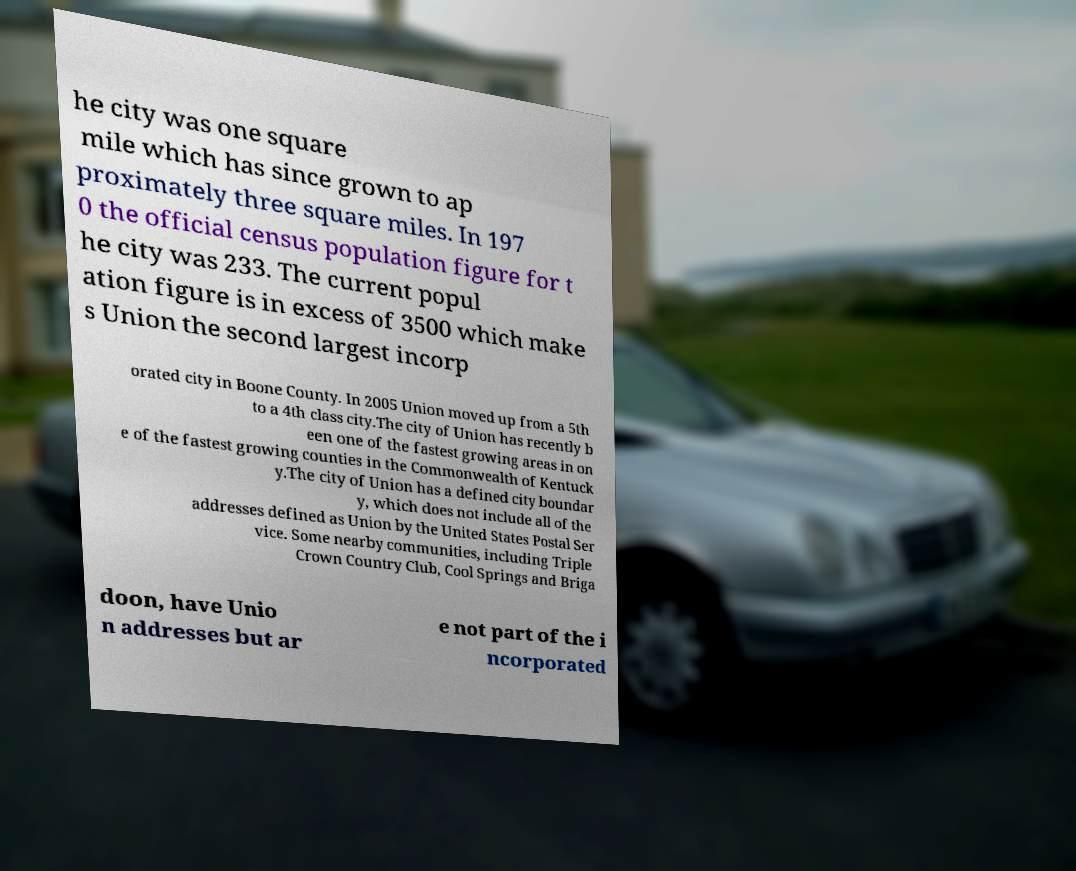Could you assist in decoding the text presented in this image and type it out clearly? he city was one square mile which has since grown to ap proximately three square miles. In 197 0 the official census population figure for t he city was 233. The current popul ation figure is in excess of 3500 which make s Union the second largest incorp orated city in Boone County. In 2005 Union moved up from a 5th to a 4th class city.The city of Union has recently b een one of the fastest growing areas in on e of the fastest growing counties in the Commonwealth of Kentuck y.The city of Union has a defined city boundar y, which does not include all of the addresses defined as Union by the United States Postal Ser vice. Some nearby communities, including Triple Crown Country Club, Cool Springs and Briga doon, have Unio n addresses but ar e not part of the i ncorporated 